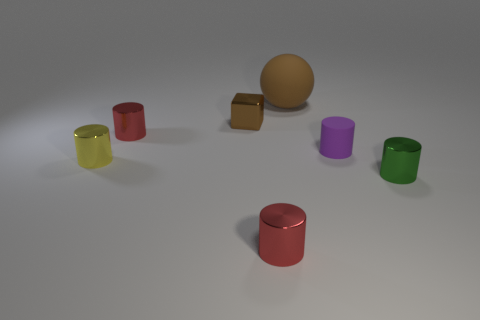Subtract all green cylinders. How many cylinders are left? 4 Subtract all purple rubber cylinders. How many cylinders are left? 4 Subtract all cyan cylinders. Subtract all green spheres. How many cylinders are left? 5 Add 2 small green shiny cylinders. How many objects exist? 9 Subtract all cylinders. How many objects are left? 2 Add 6 tiny red cylinders. How many tiny red cylinders exist? 8 Subtract 1 brown blocks. How many objects are left? 6 Subtract all small green metal objects. Subtract all tiny yellow cylinders. How many objects are left? 5 Add 5 large rubber objects. How many large rubber objects are left? 6 